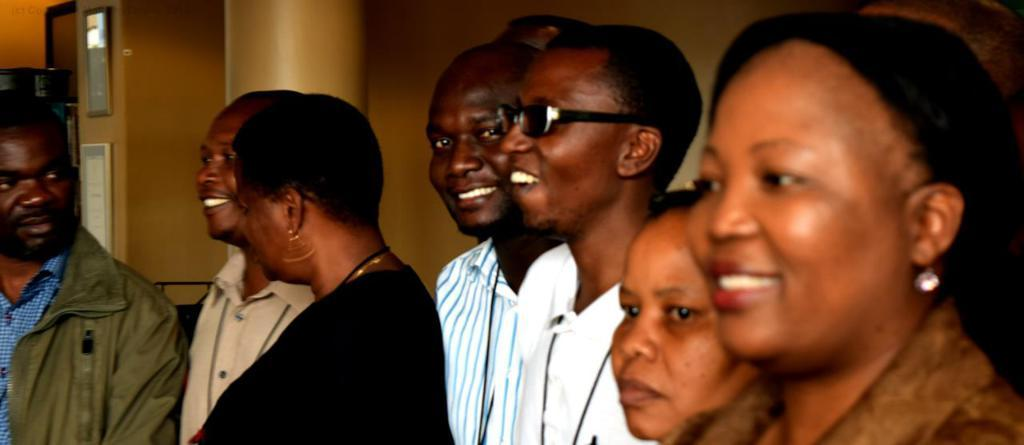What is the main subject of the image? The main subject of the image is a group of persons standing in the center. What can be seen in the background of the image? In the background, there is a pillar, photo frames, and a wall. What type of wave can be seen crashing on the shore in the image? There is no wave or shore present in the image; it features a group of persons standing in the center with a background of a pillar, photo frames, and a wall. 